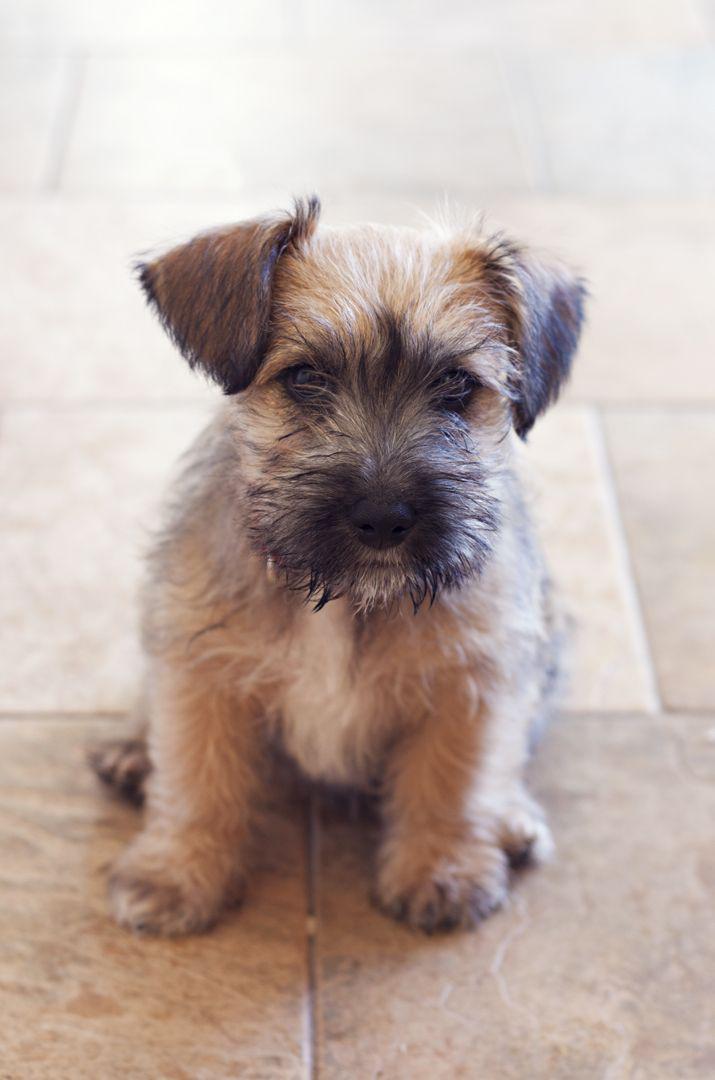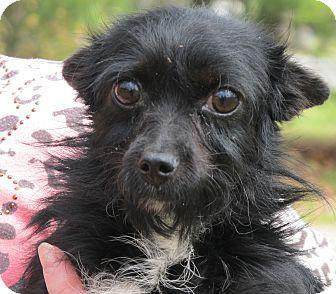The first image is the image on the left, the second image is the image on the right. Examine the images to the left and right. Is the description "There are three dogs waiting at attention." accurate? Answer yes or no. No. The first image is the image on the left, the second image is the image on the right. Analyze the images presented: Is the assertion "Two black puppies are side-by-side and turned forward in the right image." valid? Answer yes or no. No. 